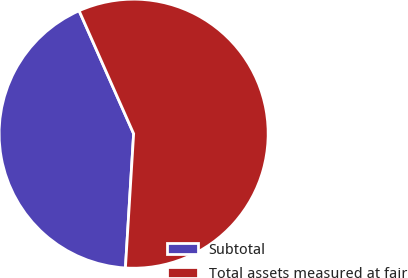<chart> <loc_0><loc_0><loc_500><loc_500><pie_chart><fcel>Subtotal<fcel>Total assets measured at fair<nl><fcel>42.38%<fcel>57.62%<nl></chart> 